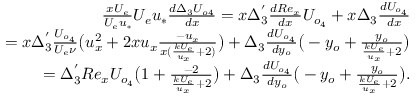Convert formula to latex. <formula><loc_0><loc_0><loc_500><loc_500>\begin{array} { r } { \frac { x U _ { e } } { U _ { e } u _ { * } } U _ { e } u _ { * } \frac { d \Delta _ { 3 } U _ { o 4 } } { d x } = x \Delta _ { 3 } ^ { ^ { \prime } } \frac { d R e _ { x } } { d x } U _ { o _ { 4 } } + x \Delta _ { 3 } \frac { d U _ { o _ { 4 } } } { d x } } \\ { = x \Delta _ { 3 } ^ { ^ { \prime } } \frac { U _ { o _ { 4 } } } { U _ { e } \nu } \left ( u _ { x } ^ { 2 } + 2 x u _ { x } \frac { - u _ { x } } { x ( \frac { k U _ { e } } { u _ { x } } + 2 ) } \right ) + \Delta _ { 3 } \frac { d U _ { o _ { 4 } } } { d y _ { o } } \left ( - y _ { o } + \frac { y _ { o } } { \frac { k U _ { e } } { u _ { x } } + 2 } \right ) } \\ { = \Delta _ { 3 } ^ { ^ { \prime } } R e _ { x } U _ { o _ { 4 } } \left ( 1 + \frac { - 2 } { \frac { k U _ { e } } { u _ { x } } + 2 } \right ) + \Delta _ { 3 } \frac { d U _ { o _ { 4 } } } { d y _ { o } } \left ( - y _ { o } + \frac { y _ { o } } { \frac { k U _ { e } } { u _ { x } } + 2 } \right ) . } \end{array}</formula> 